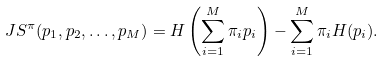Convert formula to latex. <formula><loc_0><loc_0><loc_500><loc_500>J S ^ { \pi } ( p _ { 1 } , p _ { 2 } , \dots , p _ { M } ) = H \left ( \sum _ { i = 1 } ^ { M } \pi _ { i } p _ { i } \right ) - \sum _ { i = 1 } ^ { M } \pi _ { i } H ( p _ { i } ) .</formula> 